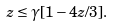Convert formula to latex. <formula><loc_0><loc_0><loc_500><loc_500>z \leq \gamma [ 1 - 4 z / 3 ] .</formula> 